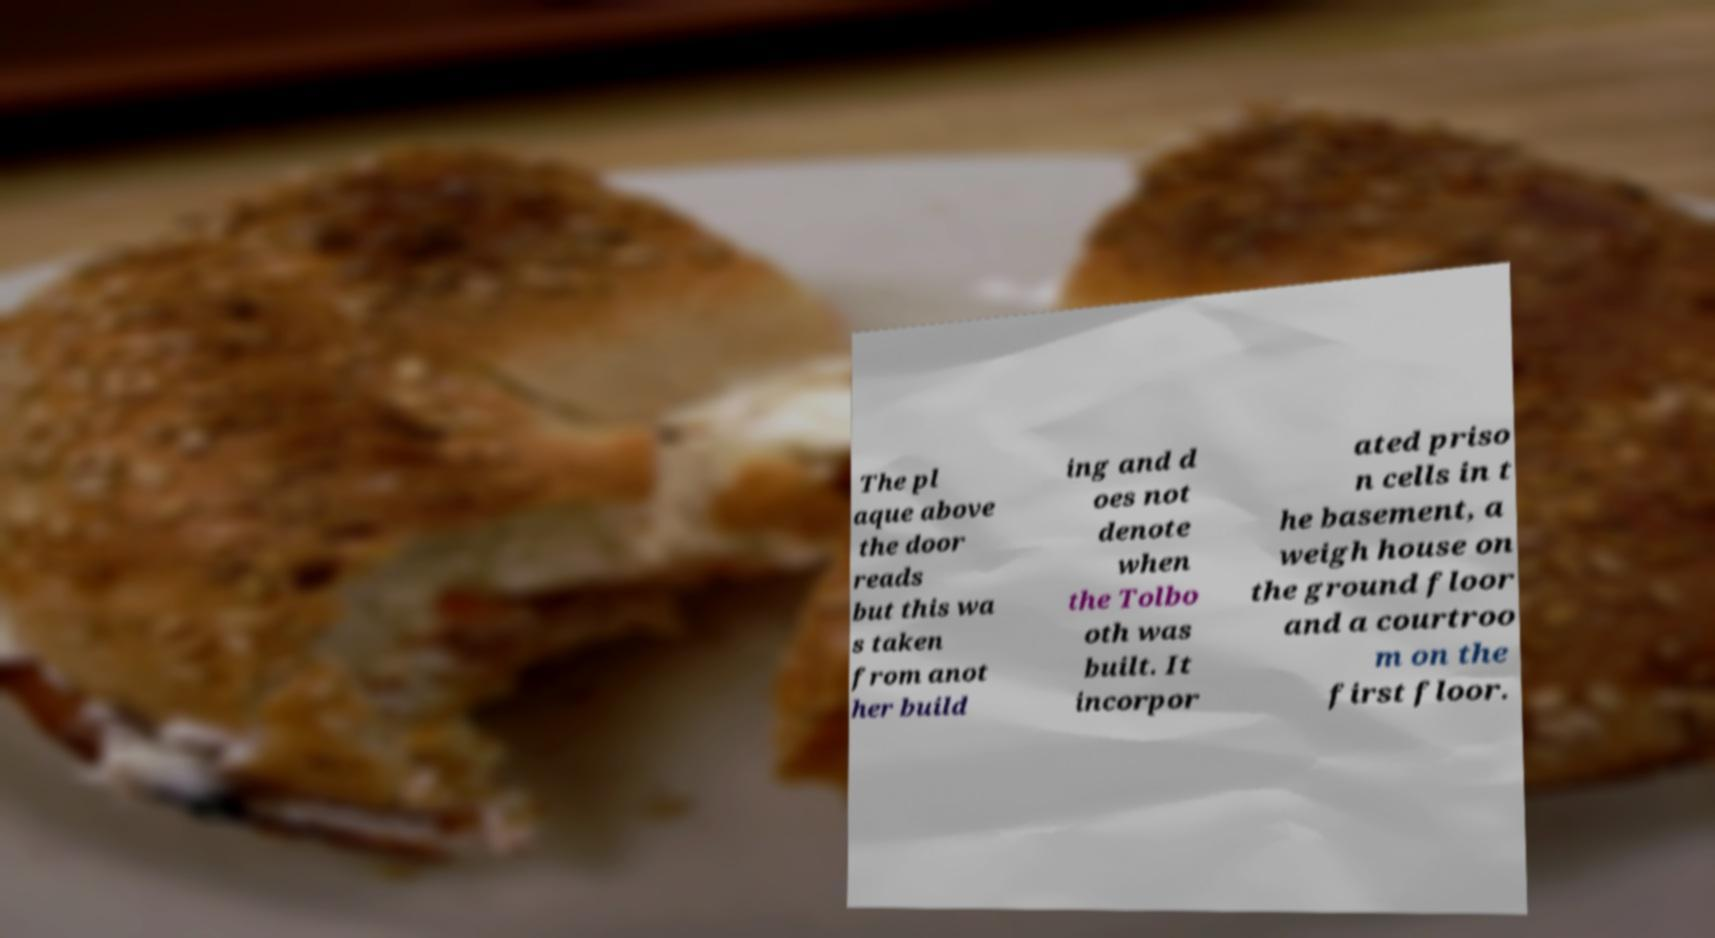What messages or text are displayed in this image? I need them in a readable, typed format. The pl aque above the door reads but this wa s taken from anot her build ing and d oes not denote when the Tolbo oth was built. It incorpor ated priso n cells in t he basement, a weigh house on the ground floor and a courtroo m on the first floor. 